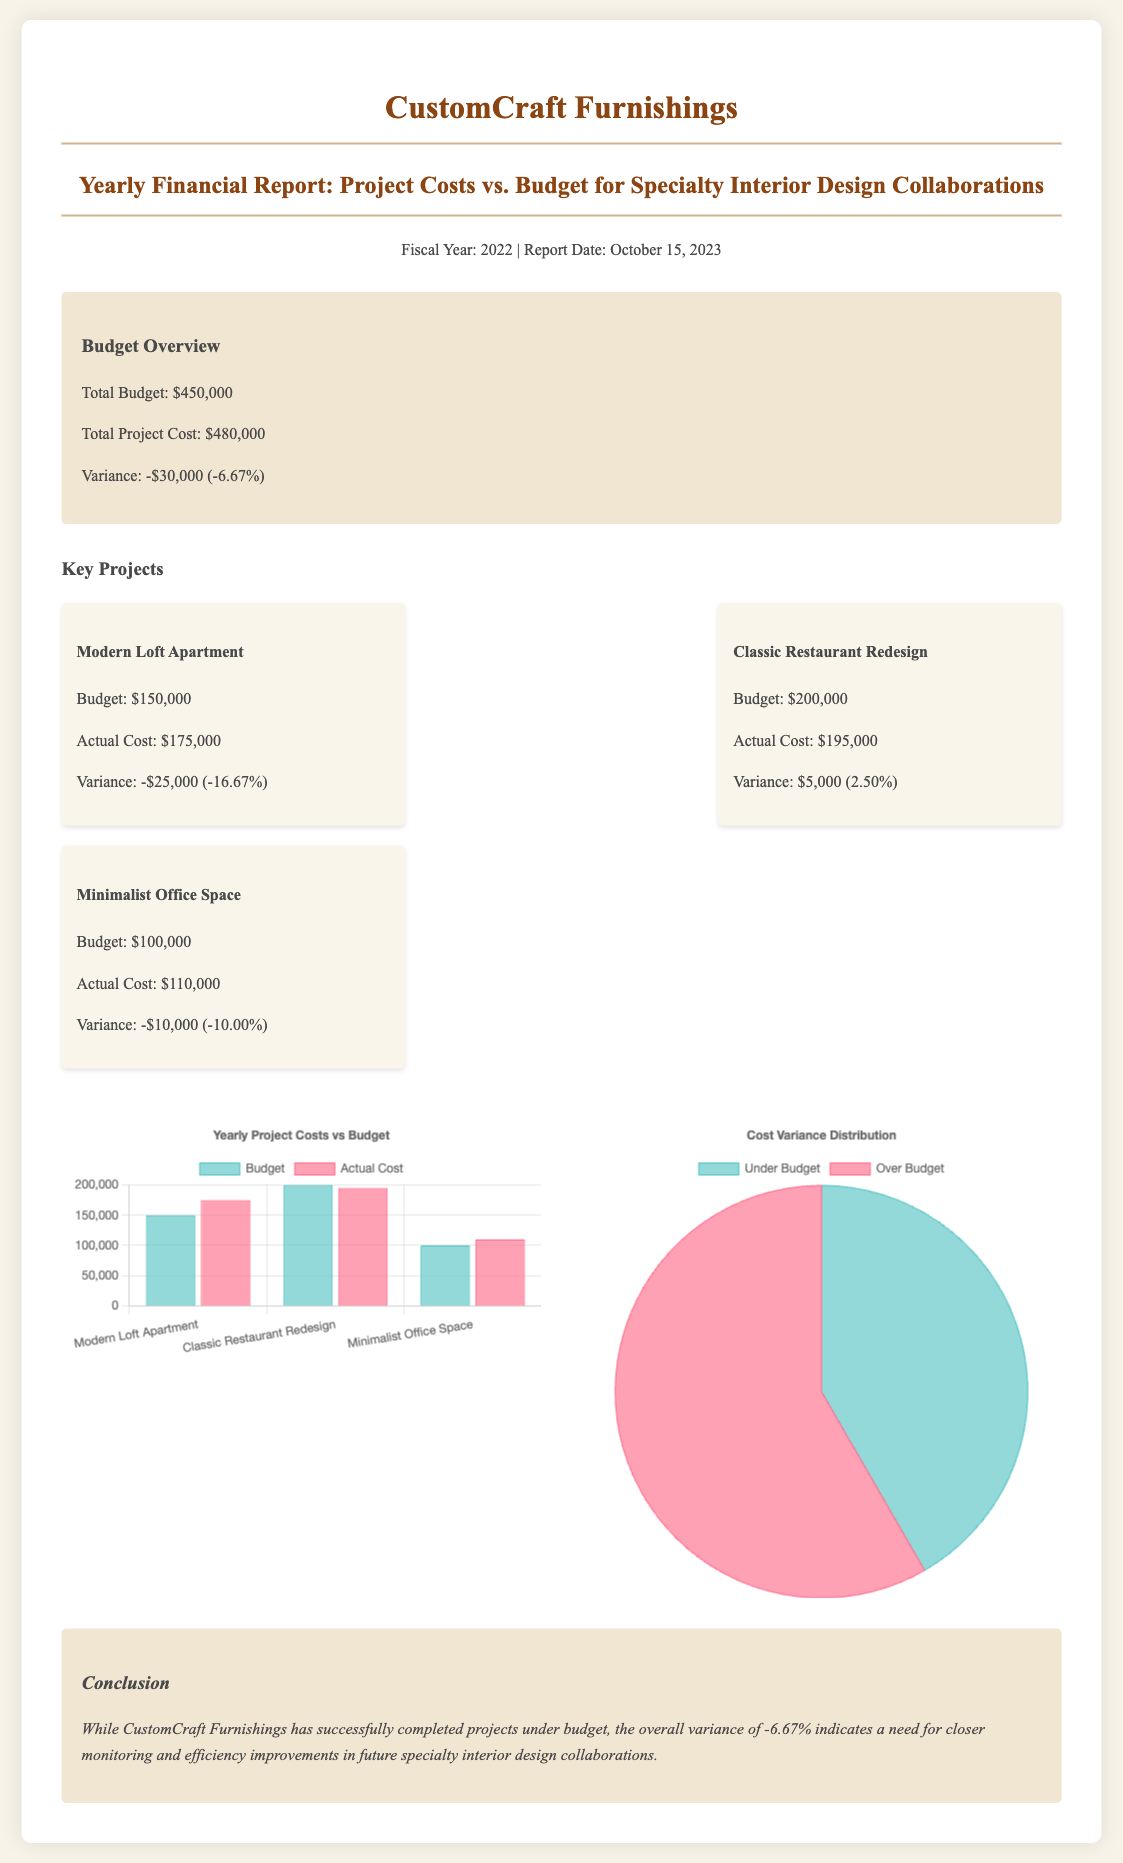what is the total budget? The total budget is listed in the overview section of the report, which states it is $450,000.
Answer: $450,000 what is the total project cost? The total project cost is provided in the overview section of the report, which states it is $480,000.
Answer: $480,000 what is the variance in total project costs? The variance is calculated from the total budget and total project cost presented in the overview, which is -$30,000 (-6.67%).
Answer: -$30,000 which project has the largest budget? The project with the largest budget can be identified in the key projects section, which is the Modern Loft Apartment at $150,000.
Answer: Modern Loft Apartment what is the variance for the Classic Restaurant Redesign project? The variance for this project is shown in the project details, which indicates it has a variance of $5,000 (2.50%).
Answer: $5,000 how many projects are under budget? The number of projects under budget can be determined from the project details; specifically, two projects are under budget.
Answer: 2 what does the pie chart represent? The pie chart in the charts section illustrates the distribution of costs between under budget and over budget categories.
Answer: Cost Variance Distribution what is the conclusion regarding project costs? The conclusion summarizes the overall finding about project costs, indicating a need for closer monitoring and efficiency improvements.
Answer: Need for closer monitoring what fiscal year does this report cover? The fiscal year covered in this report is mentioned in the header, which states it is for the year 2022.
Answer: 2022 